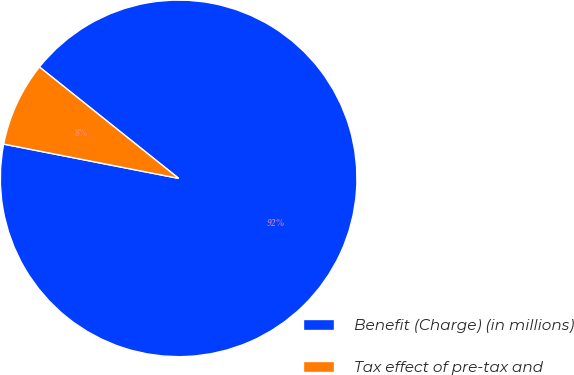<chart> <loc_0><loc_0><loc_500><loc_500><pie_chart><fcel>Benefit (Charge) (in millions)<fcel>Tax effect of pre-tax and<nl><fcel>92.34%<fcel>7.66%<nl></chart> 